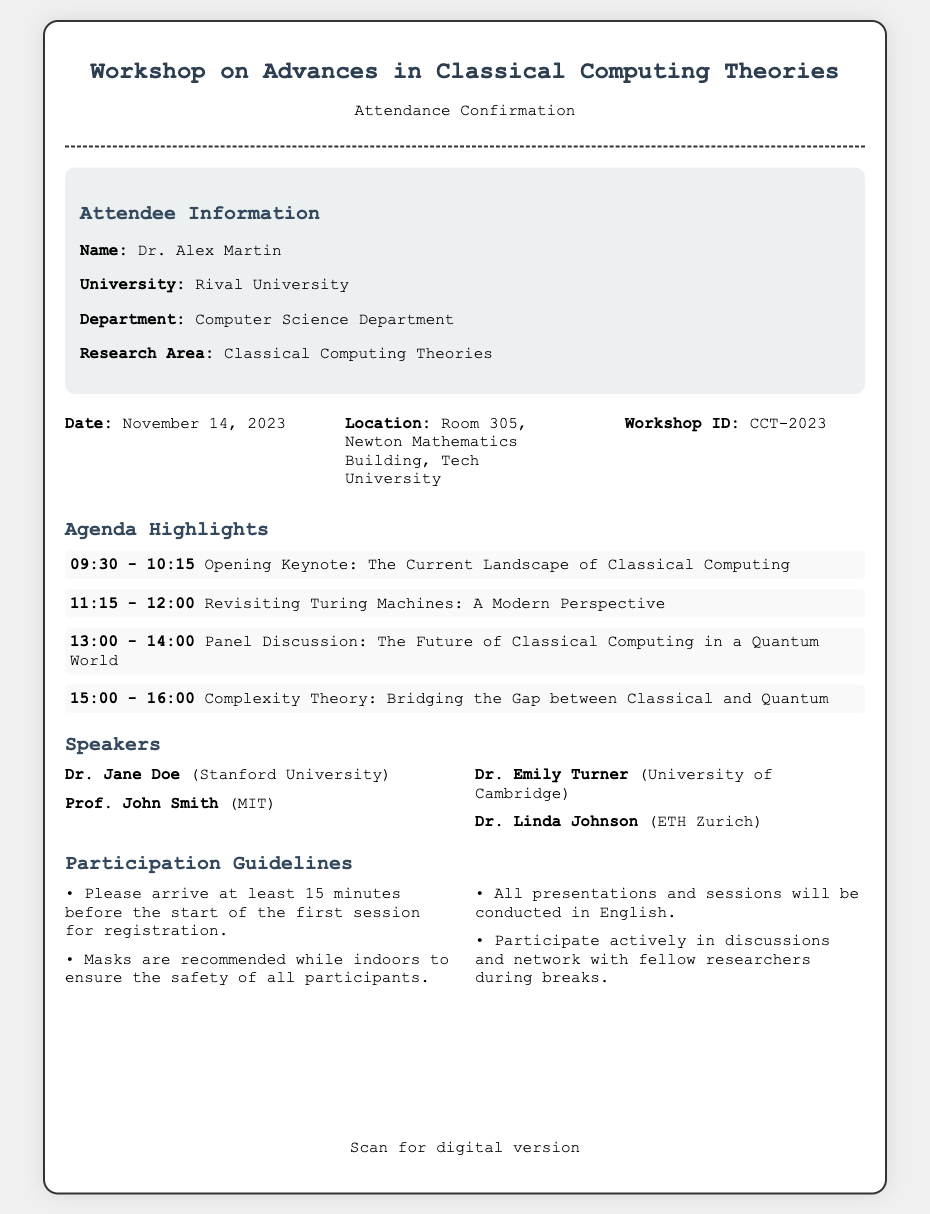What is the workshop date? The workshop date is stated clearly in the document under workshop details.
Answer: November 14, 2023 Who is hosting the opening keynote? The opening keynote speaker is mentioned in the agenda highlights section of the document.
Answer: Dr. Jane Doe What is the location of the workshop? The location of the workshop is provided in the workshop details section.
Answer: Room 305, Newton Mathematics Building, Tech University How many speakers are listed? The number of speakers is indicated in the speakers section of the document.
Answer: Four What should participants do 15 minutes before the first session? The guideline suggests an action participants should take regarding timing before the session starts.
Answer: Arrive for registration Which research area does the attendee focus on? The attendee's focus area is provided in the attendee information section of the document.
Answer: Classical Computing Theories What is the workshop ID? The workshop ID is explicitly listed in the workshop details section.
Answer: CCT-2023 What is one of the participation guidelines regarding masks? The guidelines include recommendations concerning the wearing of masks indoors.
Answer: Masks are recommended What time does the panel discussion start? The time for the panel discussion is included in the agenda highlights.
Answer: 13:00 